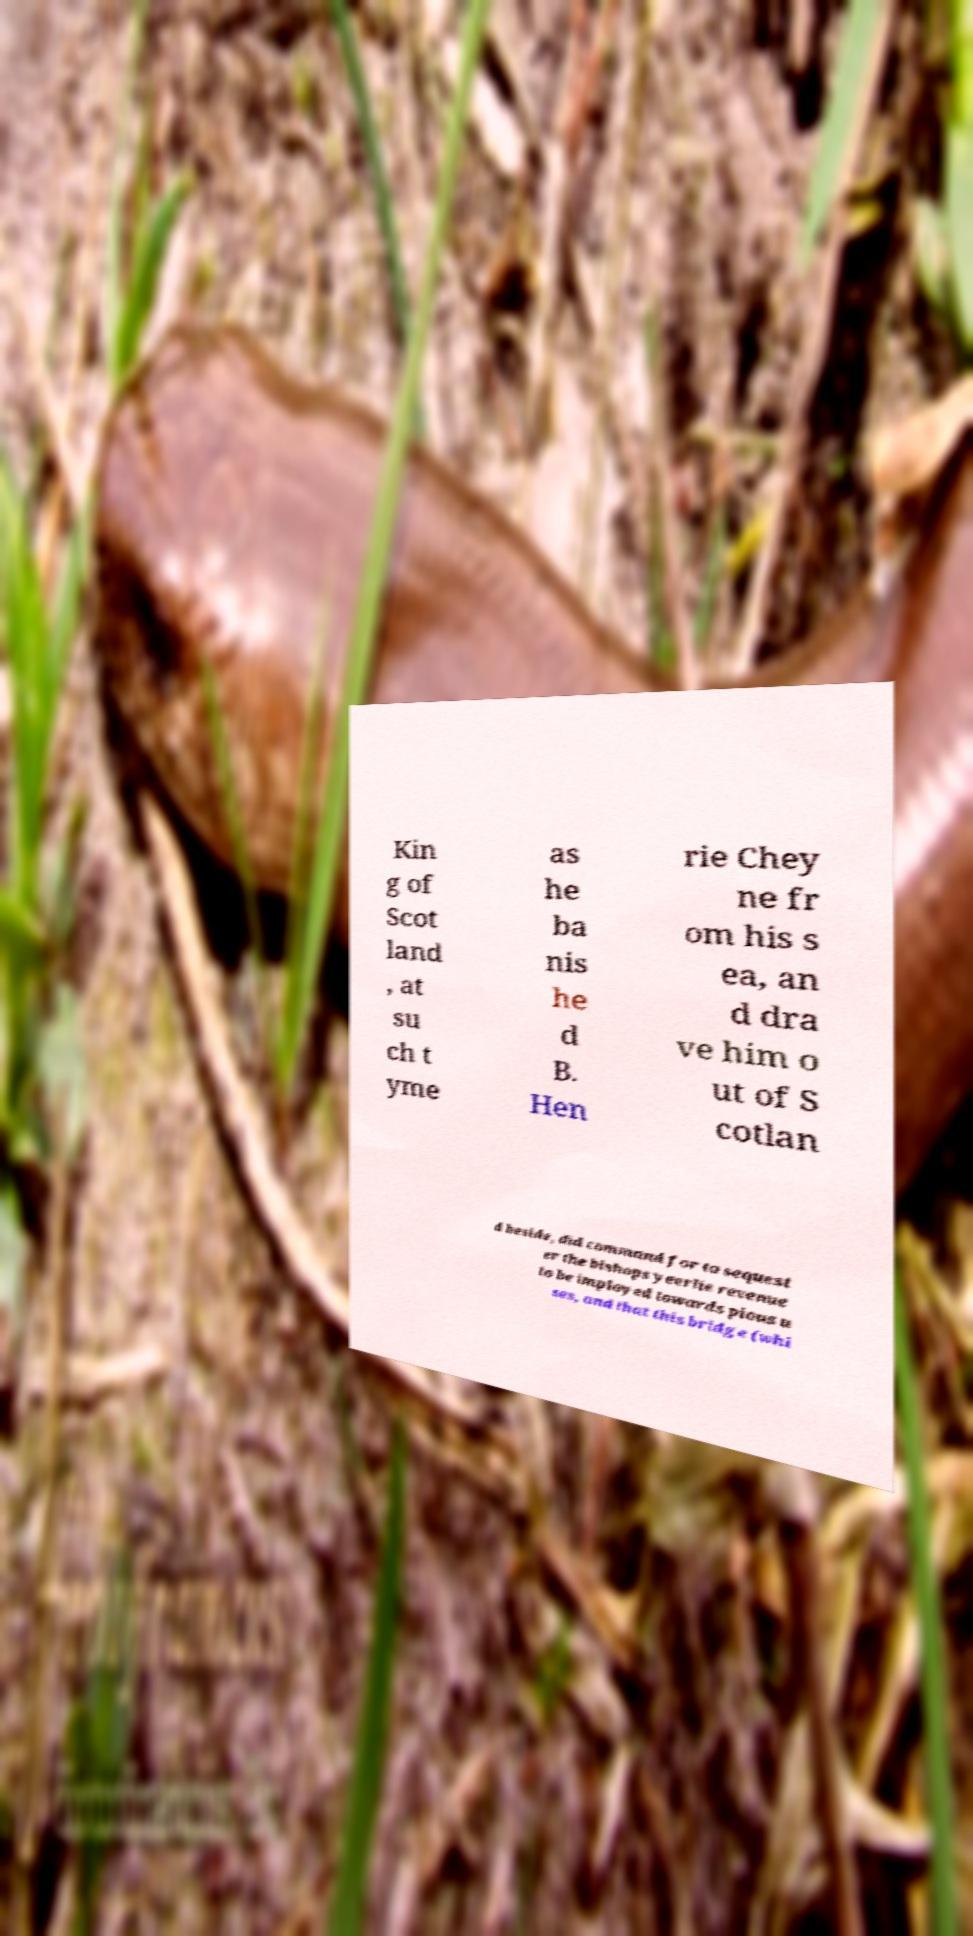Please read and relay the text visible in this image. What does it say? Kin g of Scot land , at su ch t yme as he ba nis he d B. Hen rie Chey ne fr om his s ea, an d dra ve him o ut of S cotlan d beside, did command for to sequest er the bishops yeerlie revenue to be imployed towards pious u ses, and that this bridge (whi 